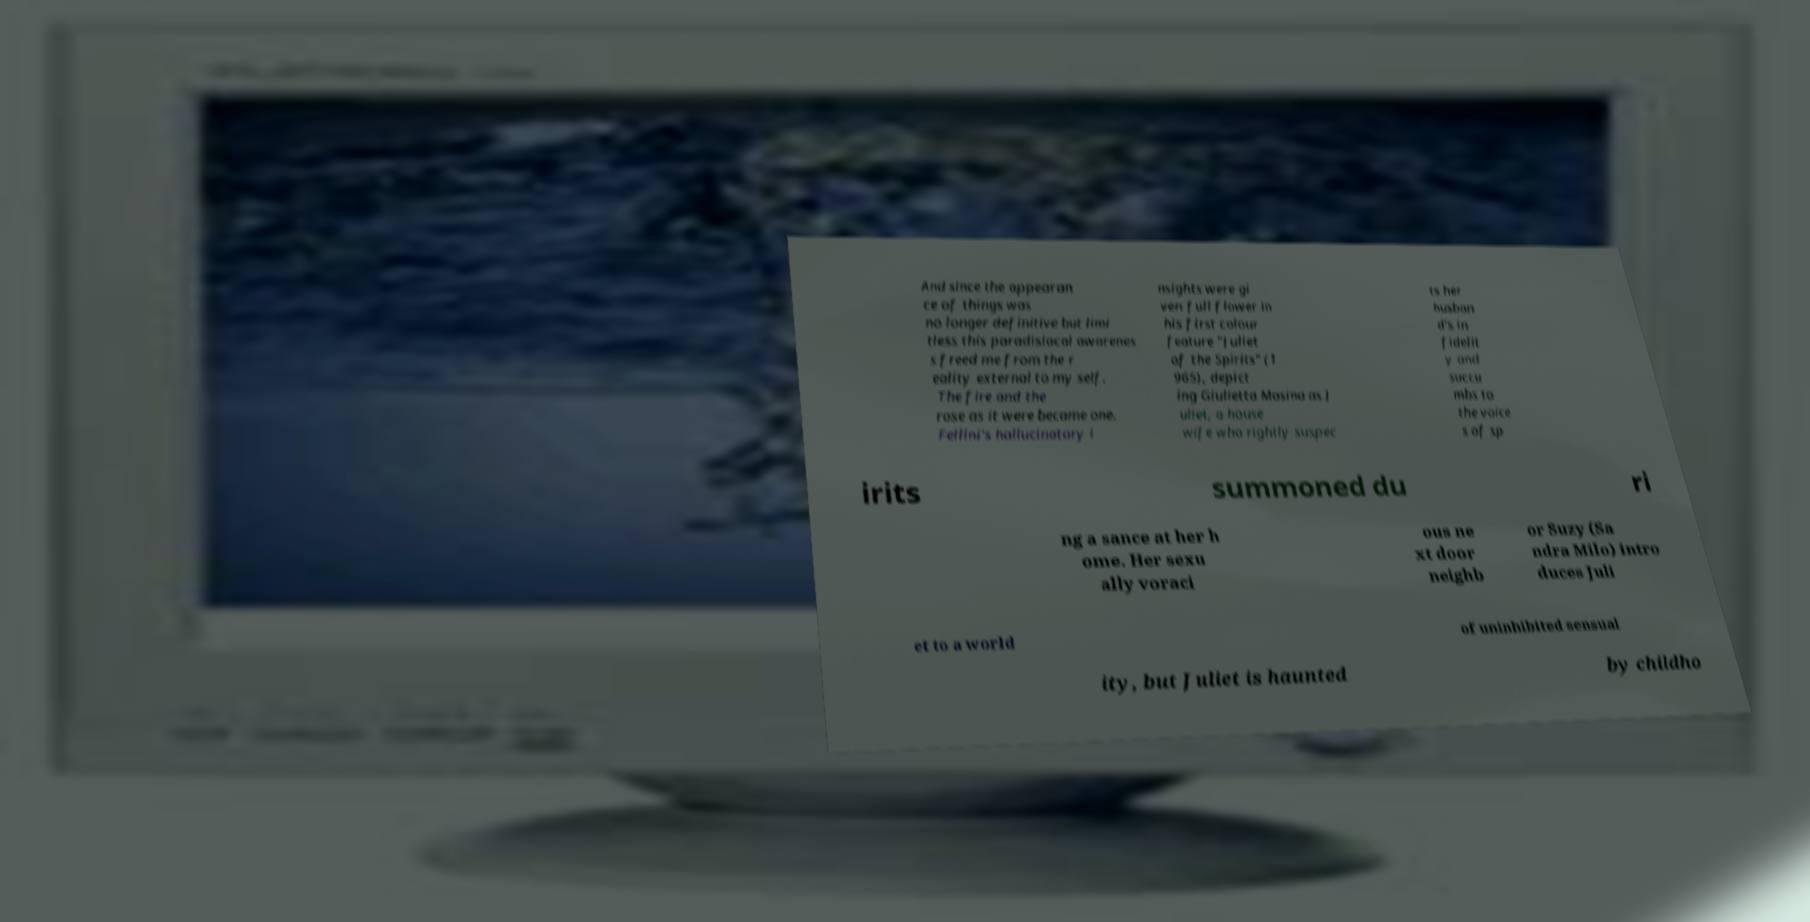Can you accurately transcribe the text from the provided image for me? And since the appearan ce of things was no longer definitive but limi tless this paradisiacal awarenes s freed me from the r eality external to my self. The fire and the rose as it were became one. Fellini's hallucinatory i nsights were gi ven full flower in his first colour feature "Juliet of the Spirits" (1 965), depict ing Giulietta Masina as J uliet, a house wife who rightly suspec ts her husban d's in fidelit y and succu mbs to the voice s of sp irits summoned du ri ng a sance at her h ome. Her sexu ally voraci ous ne xt door neighb or Suzy (Sa ndra Milo) intro duces Juli et to a world of uninhibited sensual ity, but Juliet is haunted by childho 